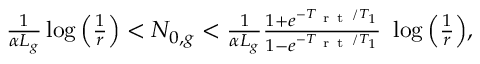<formula> <loc_0><loc_0><loc_500><loc_500>\begin{array} { r } { \frac { 1 } { \alpha L _ { g } } \log \left ( \frac { 1 } { r } \right ) < N _ { 0 , g } < \frac { 1 } { \alpha L _ { g } } \frac { 1 + e ^ { - T _ { r t } / T _ { 1 } } } { 1 - e ^ { - T _ { r t } / T _ { 1 } } } \ \log \left ( \frac { 1 } { r } \right ) , } \end{array}</formula> 